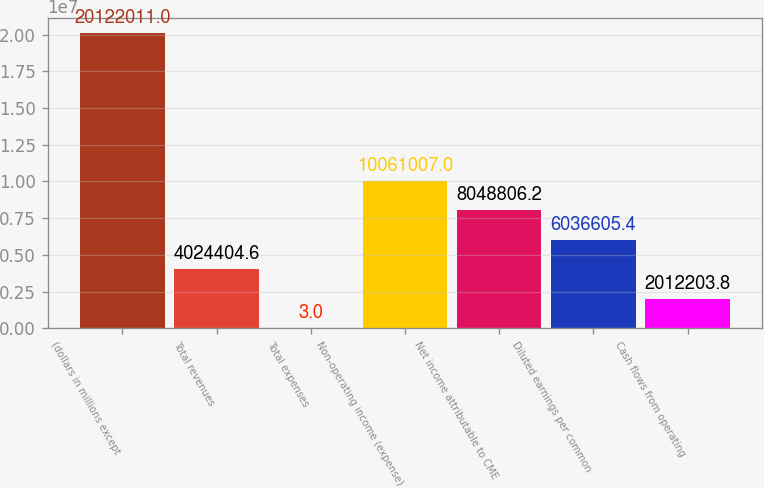<chart> <loc_0><loc_0><loc_500><loc_500><bar_chart><fcel>(dollars in millions except<fcel>Total revenues<fcel>Total expenses<fcel>Non-operating income (expense)<fcel>Net income attributable to CME<fcel>Diluted earnings per common<fcel>Cash flows from operating<nl><fcel>2.0122e+07<fcel>4.0244e+06<fcel>3<fcel>1.0061e+07<fcel>8.04881e+06<fcel>6.03661e+06<fcel>2.0122e+06<nl></chart> 